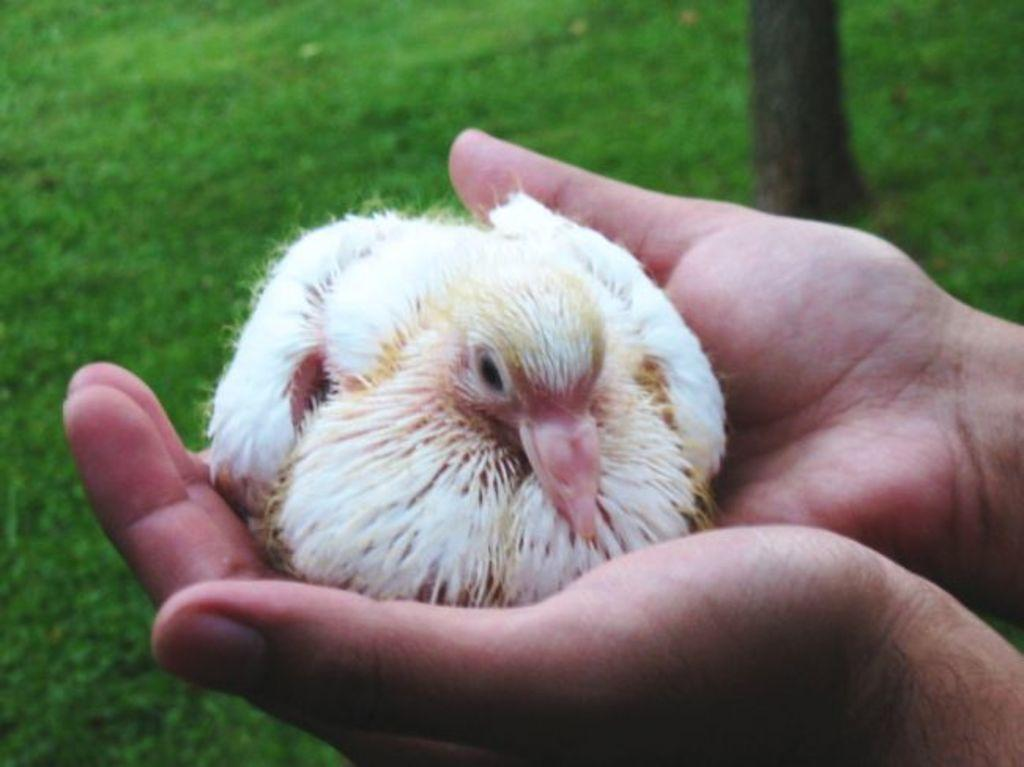What body parts of a person are visible in the image? There are a person's hands visible in the image. What is the person holding in their hands? There is a bird in the person's hands. What type of surface is visible at the bottom of the image? There is grass visible at the bottom of the image. Where is the clock located in the image? There is no clock present in the image. What type of root can be seen growing from the bird's feet in the image? There is no root visible in the image, and the bird is not shown to have any feet. 